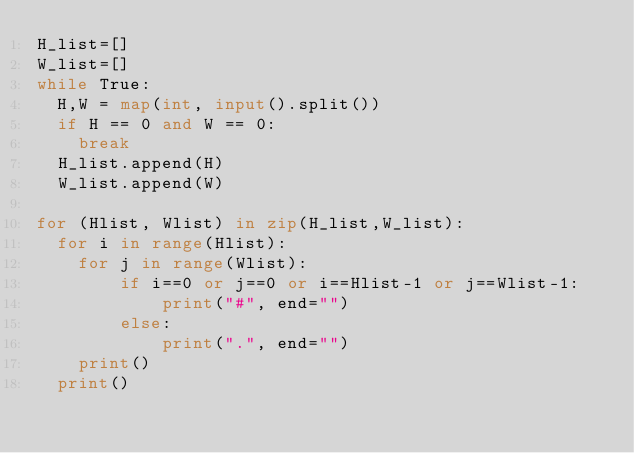<code> <loc_0><loc_0><loc_500><loc_500><_Python_>H_list=[]
W_list=[]
while True:
  H,W = map(int, input().split())
  if H == 0 and W == 0: 
    break
  H_list.append(H)
  W_list.append(W)
  
for (Hlist, Wlist) in zip(H_list,W_list):
  for i in range(Hlist):
    for j in range(Wlist):
        if i==0 or j==0 or i==Hlist-1 or j==Wlist-1: 
            print("#", end="")
        else:
            print(".", end="")
    print()
  print()
</code> 